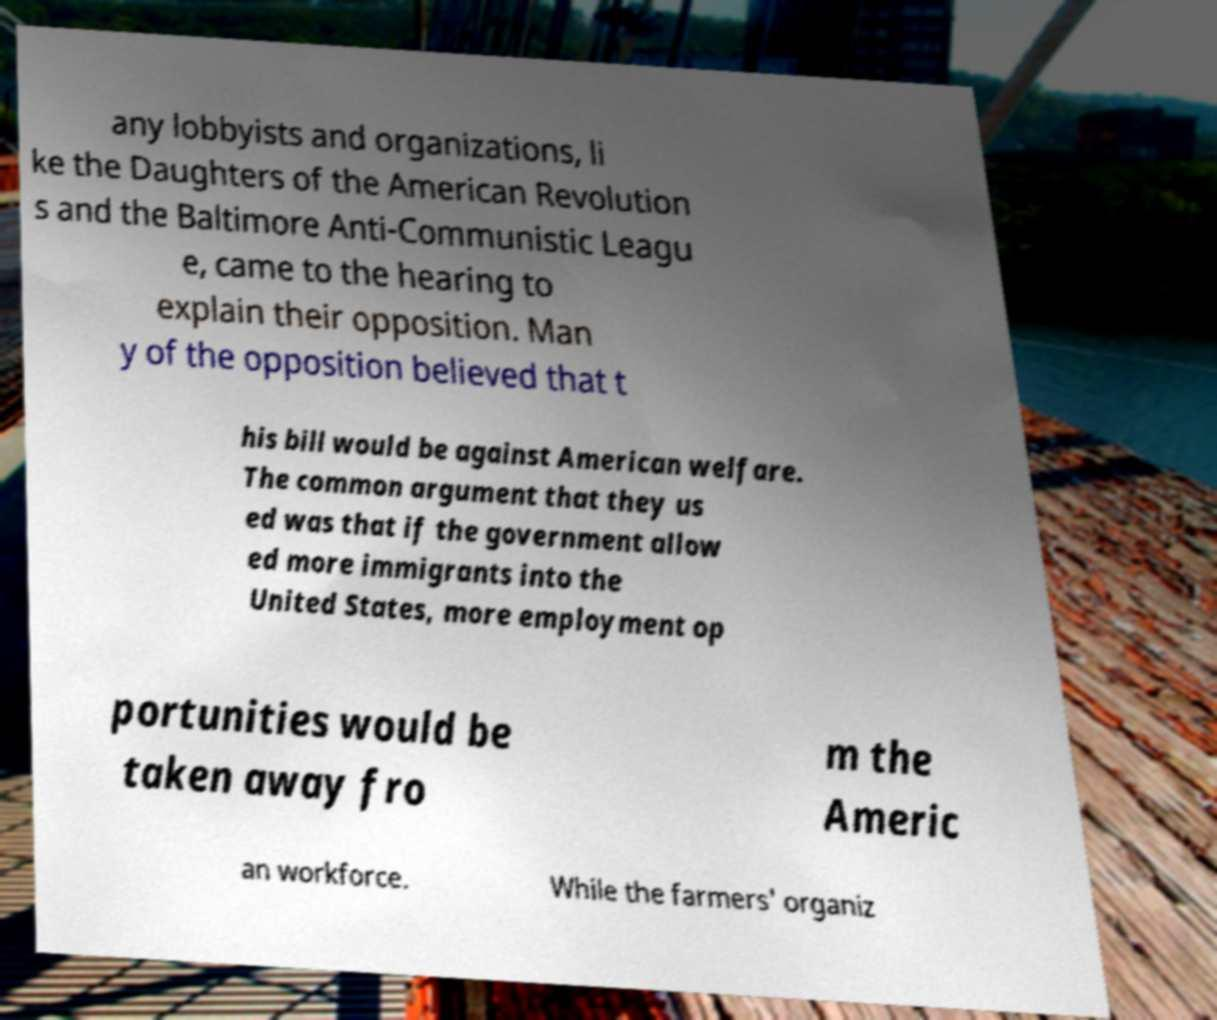Please identify and transcribe the text found in this image. any lobbyists and organizations, li ke the Daughters of the American Revolution s and the Baltimore Anti-Communistic Leagu e, came to the hearing to explain their opposition. Man y of the opposition believed that t his bill would be against American welfare. The common argument that they us ed was that if the government allow ed more immigrants into the United States, more employment op portunities would be taken away fro m the Americ an workforce. While the farmers' organiz 